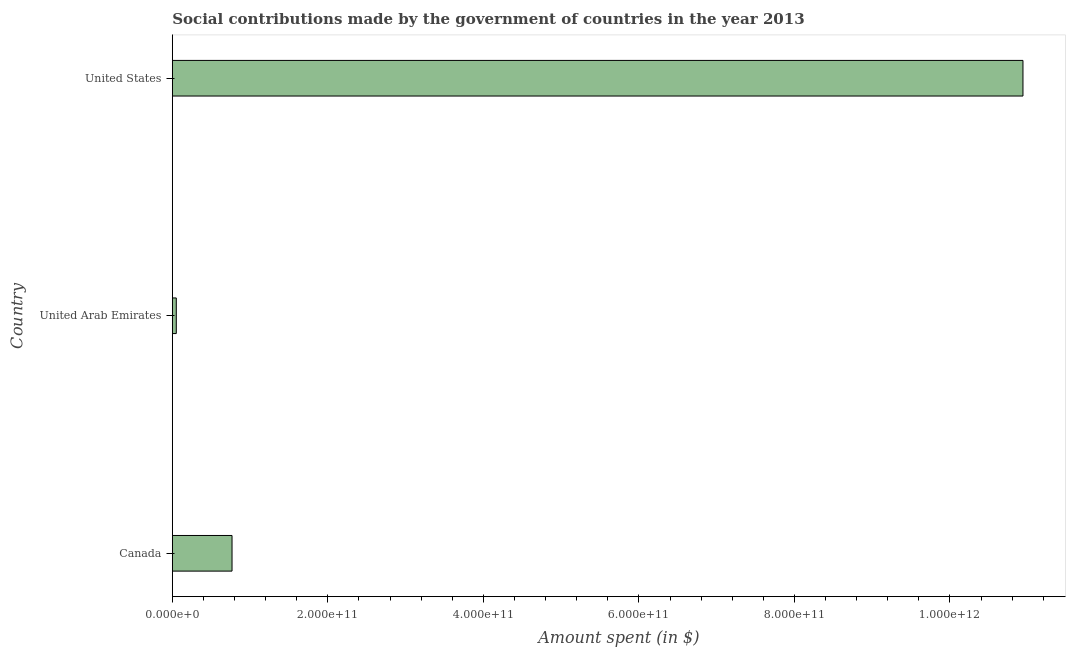Does the graph contain grids?
Offer a very short reply. No. What is the title of the graph?
Ensure brevity in your answer.  Social contributions made by the government of countries in the year 2013. What is the label or title of the X-axis?
Ensure brevity in your answer.  Amount spent (in $). What is the label or title of the Y-axis?
Keep it short and to the point. Country. What is the amount spent in making social contributions in United States?
Give a very brief answer. 1.09e+12. Across all countries, what is the maximum amount spent in making social contributions?
Your response must be concise. 1.09e+12. Across all countries, what is the minimum amount spent in making social contributions?
Your answer should be compact. 5.08e+09. In which country was the amount spent in making social contributions maximum?
Provide a short and direct response. United States. In which country was the amount spent in making social contributions minimum?
Your answer should be very brief. United Arab Emirates. What is the sum of the amount spent in making social contributions?
Ensure brevity in your answer.  1.18e+12. What is the difference between the amount spent in making social contributions in Canada and United States?
Provide a short and direct response. -1.02e+12. What is the average amount spent in making social contributions per country?
Provide a short and direct response. 3.92e+11. What is the median amount spent in making social contributions?
Give a very brief answer. 7.68e+1. In how many countries, is the amount spent in making social contributions greater than 480000000000 $?
Make the answer very short. 1. What is the ratio of the amount spent in making social contributions in Canada to that in United Arab Emirates?
Give a very brief answer. 15.11. Is the difference between the amount spent in making social contributions in United Arab Emirates and United States greater than the difference between any two countries?
Give a very brief answer. Yes. What is the difference between the highest and the second highest amount spent in making social contributions?
Ensure brevity in your answer.  1.02e+12. Is the sum of the amount spent in making social contributions in Canada and United Arab Emirates greater than the maximum amount spent in making social contributions across all countries?
Ensure brevity in your answer.  No. What is the difference between the highest and the lowest amount spent in making social contributions?
Offer a very short reply. 1.09e+12. In how many countries, is the amount spent in making social contributions greater than the average amount spent in making social contributions taken over all countries?
Ensure brevity in your answer.  1. How many bars are there?
Ensure brevity in your answer.  3. What is the difference between two consecutive major ticks on the X-axis?
Your response must be concise. 2.00e+11. What is the Amount spent (in $) of Canada?
Ensure brevity in your answer.  7.68e+1. What is the Amount spent (in $) of United Arab Emirates?
Give a very brief answer. 5.08e+09. What is the Amount spent (in $) of United States?
Keep it short and to the point. 1.09e+12. What is the difference between the Amount spent (in $) in Canada and United Arab Emirates?
Offer a terse response. 7.17e+1. What is the difference between the Amount spent (in $) in Canada and United States?
Your answer should be compact. -1.02e+12. What is the difference between the Amount spent (in $) in United Arab Emirates and United States?
Offer a very short reply. -1.09e+12. What is the ratio of the Amount spent (in $) in Canada to that in United Arab Emirates?
Provide a succinct answer. 15.11. What is the ratio of the Amount spent (in $) in Canada to that in United States?
Your answer should be compact. 0.07. What is the ratio of the Amount spent (in $) in United Arab Emirates to that in United States?
Give a very brief answer. 0.01. 